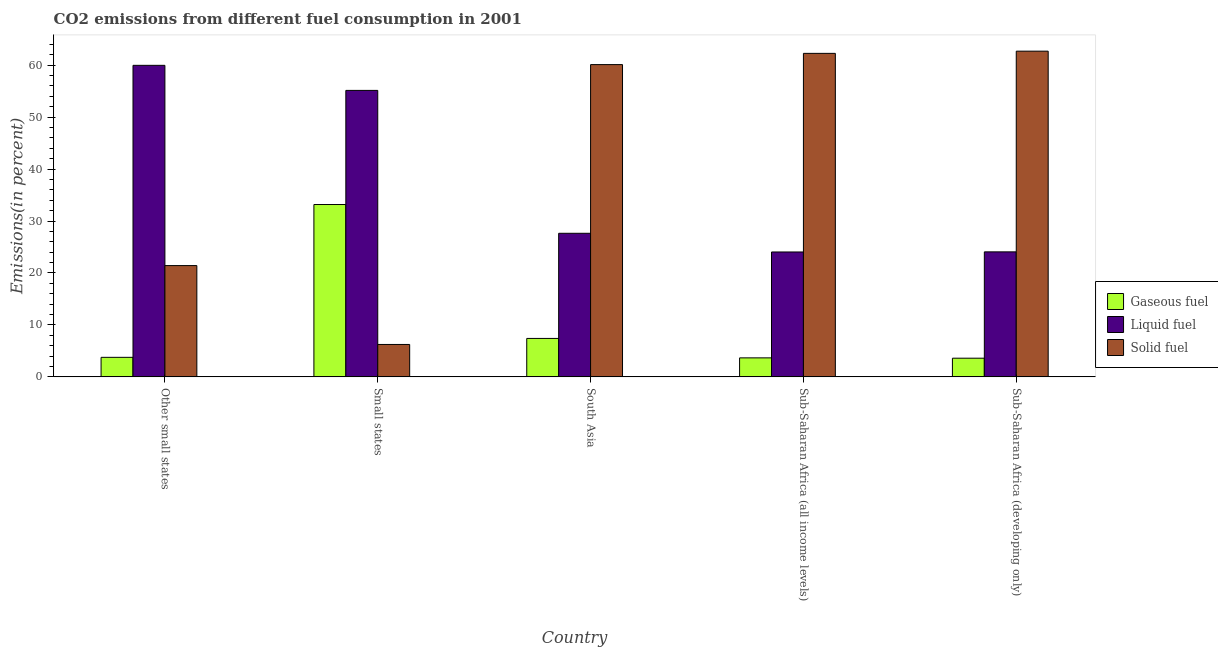Are the number of bars per tick equal to the number of legend labels?
Your answer should be compact. Yes. How many bars are there on the 2nd tick from the left?
Ensure brevity in your answer.  3. What is the label of the 5th group of bars from the left?
Keep it short and to the point. Sub-Saharan Africa (developing only). In how many cases, is the number of bars for a given country not equal to the number of legend labels?
Ensure brevity in your answer.  0. What is the percentage of liquid fuel emission in Small states?
Give a very brief answer. 55.14. Across all countries, what is the maximum percentage of solid fuel emission?
Keep it short and to the point. 62.69. Across all countries, what is the minimum percentage of gaseous fuel emission?
Offer a terse response. 3.59. In which country was the percentage of liquid fuel emission maximum?
Ensure brevity in your answer.  Other small states. In which country was the percentage of solid fuel emission minimum?
Make the answer very short. Small states. What is the total percentage of solid fuel emission in the graph?
Give a very brief answer. 212.72. What is the difference between the percentage of solid fuel emission in Small states and that in Sub-Saharan Africa (all income levels)?
Your answer should be compact. -56.03. What is the difference between the percentage of gaseous fuel emission in Sub-Saharan Africa (all income levels) and the percentage of liquid fuel emission in Other small states?
Your answer should be compact. -56.3. What is the average percentage of solid fuel emission per country?
Your answer should be compact. 42.54. What is the difference between the percentage of liquid fuel emission and percentage of solid fuel emission in Other small states?
Keep it short and to the point. 38.54. In how many countries, is the percentage of gaseous fuel emission greater than 16 %?
Your response must be concise. 1. What is the ratio of the percentage of solid fuel emission in Other small states to that in South Asia?
Your answer should be compact. 0.36. Is the difference between the percentage of gaseous fuel emission in Other small states and Small states greater than the difference between the percentage of solid fuel emission in Other small states and Small states?
Offer a very short reply. No. What is the difference between the highest and the second highest percentage of liquid fuel emission?
Give a very brief answer. 4.82. What is the difference between the highest and the lowest percentage of gaseous fuel emission?
Offer a terse response. 29.58. Is the sum of the percentage of gaseous fuel emission in Small states and South Asia greater than the maximum percentage of solid fuel emission across all countries?
Provide a succinct answer. No. What does the 2nd bar from the left in Small states represents?
Your response must be concise. Liquid fuel. What does the 2nd bar from the right in South Asia represents?
Your answer should be compact. Liquid fuel. How many bars are there?
Give a very brief answer. 15. Does the graph contain any zero values?
Provide a short and direct response. No. How many legend labels are there?
Your answer should be very brief. 3. What is the title of the graph?
Offer a terse response. CO2 emissions from different fuel consumption in 2001. What is the label or title of the Y-axis?
Your answer should be very brief. Emissions(in percent). What is the Emissions(in percent) of Gaseous fuel in Other small states?
Ensure brevity in your answer.  3.76. What is the Emissions(in percent) in Liquid fuel in Other small states?
Give a very brief answer. 59.96. What is the Emissions(in percent) of Solid fuel in Other small states?
Provide a succinct answer. 21.42. What is the Emissions(in percent) in Gaseous fuel in Small states?
Give a very brief answer. 33.17. What is the Emissions(in percent) in Liquid fuel in Small states?
Make the answer very short. 55.14. What is the Emissions(in percent) in Solid fuel in Small states?
Provide a short and direct response. 6.24. What is the Emissions(in percent) in Gaseous fuel in South Asia?
Ensure brevity in your answer.  7.4. What is the Emissions(in percent) of Liquid fuel in South Asia?
Ensure brevity in your answer.  27.63. What is the Emissions(in percent) in Solid fuel in South Asia?
Your answer should be very brief. 60.1. What is the Emissions(in percent) in Gaseous fuel in Sub-Saharan Africa (all income levels)?
Your answer should be compact. 3.66. What is the Emissions(in percent) in Liquid fuel in Sub-Saharan Africa (all income levels)?
Ensure brevity in your answer.  24.04. What is the Emissions(in percent) of Solid fuel in Sub-Saharan Africa (all income levels)?
Give a very brief answer. 62.27. What is the Emissions(in percent) in Gaseous fuel in Sub-Saharan Africa (developing only)?
Give a very brief answer. 3.59. What is the Emissions(in percent) of Liquid fuel in Sub-Saharan Africa (developing only)?
Offer a terse response. 24.06. What is the Emissions(in percent) of Solid fuel in Sub-Saharan Africa (developing only)?
Provide a short and direct response. 62.69. Across all countries, what is the maximum Emissions(in percent) of Gaseous fuel?
Provide a short and direct response. 33.17. Across all countries, what is the maximum Emissions(in percent) in Liquid fuel?
Offer a very short reply. 59.96. Across all countries, what is the maximum Emissions(in percent) in Solid fuel?
Provide a short and direct response. 62.69. Across all countries, what is the minimum Emissions(in percent) in Gaseous fuel?
Your response must be concise. 3.59. Across all countries, what is the minimum Emissions(in percent) in Liquid fuel?
Ensure brevity in your answer.  24.04. Across all countries, what is the minimum Emissions(in percent) in Solid fuel?
Make the answer very short. 6.24. What is the total Emissions(in percent) of Gaseous fuel in the graph?
Provide a succinct answer. 51.58. What is the total Emissions(in percent) in Liquid fuel in the graph?
Ensure brevity in your answer.  190.84. What is the total Emissions(in percent) in Solid fuel in the graph?
Offer a very short reply. 212.72. What is the difference between the Emissions(in percent) in Gaseous fuel in Other small states and that in Small states?
Provide a succinct answer. -29.41. What is the difference between the Emissions(in percent) in Liquid fuel in Other small states and that in Small states?
Your answer should be compact. 4.82. What is the difference between the Emissions(in percent) of Solid fuel in Other small states and that in Small states?
Make the answer very short. 15.18. What is the difference between the Emissions(in percent) in Gaseous fuel in Other small states and that in South Asia?
Provide a succinct answer. -3.64. What is the difference between the Emissions(in percent) of Liquid fuel in Other small states and that in South Asia?
Your answer should be compact. 32.33. What is the difference between the Emissions(in percent) of Solid fuel in Other small states and that in South Asia?
Offer a terse response. -38.69. What is the difference between the Emissions(in percent) in Gaseous fuel in Other small states and that in Sub-Saharan Africa (all income levels)?
Offer a terse response. 0.1. What is the difference between the Emissions(in percent) of Liquid fuel in Other small states and that in Sub-Saharan Africa (all income levels)?
Your response must be concise. 35.92. What is the difference between the Emissions(in percent) in Solid fuel in Other small states and that in Sub-Saharan Africa (all income levels)?
Make the answer very short. -40.85. What is the difference between the Emissions(in percent) in Gaseous fuel in Other small states and that in Sub-Saharan Africa (developing only)?
Provide a succinct answer. 0.17. What is the difference between the Emissions(in percent) in Liquid fuel in Other small states and that in Sub-Saharan Africa (developing only)?
Provide a short and direct response. 35.9. What is the difference between the Emissions(in percent) in Solid fuel in Other small states and that in Sub-Saharan Africa (developing only)?
Offer a very short reply. -41.27. What is the difference between the Emissions(in percent) of Gaseous fuel in Small states and that in South Asia?
Your response must be concise. 25.77. What is the difference between the Emissions(in percent) in Liquid fuel in Small states and that in South Asia?
Keep it short and to the point. 27.5. What is the difference between the Emissions(in percent) in Solid fuel in Small states and that in South Asia?
Give a very brief answer. -53.87. What is the difference between the Emissions(in percent) of Gaseous fuel in Small states and that in Sub-Saharan Africa (all income levels)?
Give a very brief answer. 29.51. What is the difference between the Emissions(in percent) of Liquid fuel in Small states and that in Sub-Saharan Africa (all income levels)?
Make the answer very short. 31.1. What is the difference between the Emissions(in percent) in Solid fuel in Small states and that in Sub-Saharan Africa (all income levels)?
Ensure brevity in your answer.  -56.03. What is the difference between the Emissions(in percent) of Gaseous fuel in Small states and that in Sub-Saharan Africa (developing only)?
Provide a succinct answer. 29.58. What is the difference between the Emissions(in percent) of Liquid fuel in Small states and that in Sub-Saharan Africa (developing only)?
Give a very brief answer. 31.08. What is the difference between the Emissions(in percent) of Solid fuel in Small states and that in Sub-Saharan Africa (developing only)?
Keep it short and to the point. -56.45. What is the difference between the Emissions(in percent) of Gaseous fuel in South Asia and that in Sub-Saharan Africa (all income levels)?
Keep it short and to the point. 3.74. What is the difference between the Emissions(in percent) in Liquid fuel in South Asia and that in Sub-Saharan Africa (all income levels)?
Your answer should be compact. 3.6. What is the difference between the Emissions(in percent) in Solid fuel in South Asia and that in Sub-Saharan Africa (all income levels)?
Offer a terse response. -2.16. What is the difference between the Emissions(in percent) in Gaseous fuel in South Asia and that in Sub-Saharan Africa (developing only)?
Keep it short and to the point. 3.8. What is the difference between the Emissions(in percent) in Liquid fuel in South Asia and that in Sub-Saharan Africa (developing only)?
Ensure brevity in your answer.  3.57. What is the difference between the Emissions(in percent) in Solid fuel in South Asia and that in Sub-Saharan Africa (developing only)?
Make the answer very short. -2.59. What is the difference between the Emissions(in percent) of Gaseous fuel in Sub-Saharan Africa (all income levels) and that in Sub-Saharan Africa (developing only)?
Your answer should be very brief. 0.06. What is the difference between the Emissions(in percent) of Liquid fuel in Sub-Saharan Africa (all income levels) and that in Sub-Saharan Africa (developing only)?
Offer a terse response. -0.02. What is the difference between the Emissions(in percent) in Solid fuel in Sub-Saharan Africa (all income levels) and that in Sub-Saharan Africa (developing only)?
Give a very brief answer. -0.42. What is the difference between the Emissions(in percent) of Gaseous fuel in Other small states and the Emissions(in percent) of Liquid fuel in Small states?
Your answer should be compact. -51.38. What is the difference between the Emissions(in percent) in Gaseous fuel in Other small states and the Emissions(in percent) in Solid fuel in Small states?
Make the answer very short. -2.48. What is the difference between the Emissions(in percent) in Liquid fuel in Other small states and the Emissions(in percent) in Solid fuel in Small states?
Give a very brief answer. 53.72. What is the difference between the Emissions(in percent) in Gaseous fuel in Other small states and the Emissions(in percent) in Liquid fuel in South Asia?
Offer a very short reply. -23.87. What is the difference between the Emissions(in percent) in Gaseous fuel in Other small states and the Emissions(in percent) in Solid fuel in South Asia?
Your answer should be compact. -56.34. What is the difference between the Emissions(in percent) of Liquid fuel in Other small states and the Emissions(in percent) of Solid fuel in South Asia?
Your answer should be compact. -0.14. What is the difference between the Emissions(in percent) of Gaseous fuel in Other small states and the Emissions(in percent) of Liquid fuel in Sub-Saharan Africa (all income levels)?
Ensure brevity in your answer.  -20.28. What is the difference between the Emissions(in percent) of Gaseous fuel in Other small states and the Emissions(in percent) of Solid fuel in Sub-Saharan Africa (all income levels)?
Ensure brevity in your answer.  -58.51. What is the difference between the Emissions(in percent) in Liquid fuel in Other small states and the Emissions(in percent) in Solid fuel in Sub-Saharan Africa (all income levels)?
Provide a succinct answer. -2.3. What is the difference between the Emissions(in percent) of Gaseous fuel in Other small states and the Emissions(in percent) of Liquid fuel in Sub-Saharan Africa (developing only)?
Provide a succinct answer. -20.3. What is the difference between the Emissions(in percent) of Gaseous fuel in Other small states and the Emissions(in percent) of Solid fuel in Sub-Saharan Africa (developing only)?
Ensure brevity in your answer.  -58.93. What is the difference between the Emissions(in percent) of Liquid fuel in Other small states and the Emissions(in percent) of Solid fuel in Sub-Saharan Africa (developing only)?
Provide a succinct answer. -2.73. What is the difference between the Emissions(in percent) in Gaseous fuel in Small states and the Emissions(in percent) in Liquid fuel in South Asia?
Ensure brevity in your answer.  5.54. What is the difference between the Emissions(in percent) of Gaseous fuel in Small states and the Emissions(in percent) of Solid fuel in South Asia?
Provide a short and direct response. -26.93. What is the difference between the Emissions(in percent) in Liquid fuel in Small states and the Emissions(in percent) in Solid fuel in South Asia?
Make the answer very short. -4.97. What is the difference between the Emissions(in percent) of Gaseous fuel in Small states and the Emissions(in percent) of Liquid fuel in Sub-Saharan Africa (all income levels)?
Provide a succinct answer. 9.13. What is the difference between the Emissions(in percent) in Gaseous fuel in Small states and the Emissions(in percent) in Solid fuel in Sub-Saharan Africa (all income levels)?
Ensure brevity in your answer.  -29.1. What is the difference between the Emissions(in percent) in Liquid fuel in Small states and the Emissions(in percent) in Solid fuel in Sub-Saharan Africa (all income levels)?
Ensure brevity in your answer.  -7.13. What is the difference between the Emissions(in percent) in Gaseous fuel in Small states and the Emissions(in percent) in Liquid fuel in Sub-Saharan Africa (developing only)?
Make the answer very short. 9.11. What is the difference between the Emissions(in percent) in Gaseous fuel in Small states and the Emissions(in percent) in Solid fuel in Sub-Saharan Africa (developing only)?
Give a very brief answer. -29.52. What is the difference between the Emissions(in percent) in Liquid fuel in Small states and the Emissions(in percent) in Solid fuel in Sub-Saharan Africa (developing only)?
Provide a short and direct response. -7.55. What is the difference between the Emissions(in percent) in Gaseous fuel in South Asia and the Emissions(in percent) in Liquid fuel in Sub-Saharan Africa (all income levels)?
Provide a short and direct response. -16.64. What is the difference between the Emissions(in percent) in Gaseous fuel in South Asia and the Emissions(in percent) in Solid fuel in Sub-Saharan Africa (all income levels)?
Your answer should be compact. -54.87. What is the difference between the Emissions(in percent) of Liquid fuel in South Asia and the Emissions(in percent) of Solid fuel in Sub-Saharan Africa (all income levels)?
Your response must be concise. -34.63. What is the difference between the Emissions(in percent) in Gaseous fuel in South Asia and the Emissions(in percent) in Liquid fuel in Sub-Saharan Africa (developing only)?
Offer a very short reply. -16.66. What is the difference between the Emissions(in percent) in Gaseous fuel in South Asia and the Emissions(in percent) in Solid fuel in Sub-Saharan Africa (developing only)?
Your answer should be compact. -55.29. What is the difference between the Emissions(in percent) of Liquid fuel in South Asia and the Emissions(in percent) of Solid fuel in Sub-Saharan Africa (developing only)?
Make the answer very short. -35.06. What is the difference between the Emissions(in percent) of Gaseous fuel in Sub-Saharan Africa (all income levels) and the Emissions(in percent) of Liquid fuel in Sub-Saharan Africa (developing only)?
Offer a very short reply. -20.4. What is the difference between the Emissions(in percent) in Gaseous fuel in Sub-Saharan Africa (all income levels) and the Emissions(in percent) in Solid fuel in Sub-Saharan Africa (developing only)?
Your answer should be compact. -59.03. What is the difference between the Emissions(in percent) of Liquid fuel in Sub-Saharan Africa (all income levels) and the Emissions(in percent) of Solid fuel in Sub-Saharan Africa (developing only)?
Make the answer very short. -38.65. What is the average Emissions(in percent) in Gaseous fuel per country?
Ensure brevity in your answer.  10.32. What is the average Emissions(in percent) of Liquid fuel per country?
Offer a terse response. 38.17. What is the average Emissions(in percent) in Solid fuel per country?
Offer a very short reply. 42.54. What is the difference between the Emissions(in percent) of Gaseous fuel and Emissions(in percent) of Liquid fuel in Other small states?
Offer a terse response. -56.2. What is the difference between the Emissions(in percent) of Gaseous fuel and Emissions(in percent) of Solid fuel in Other small states?
Provide a succinct answer. -17.66. What is the difference between the Emissions(in percent) in Liquid fuel and Emissions(in percent) in Solid fuel in Other small states?
Your response must be concise. 38.54. What is the difference between the Emissions(in percent) of Gaseous fuel and Emissions(in percent) of Liquid fuel in Small states?
Give a very brief answer. -21.97. What is the difference between the Emissions(in percent) in Gaseous fuel and Emissions(in percent) in Solid fuel in Small states?
Offer a very short reply. 26.93. What is the difference between the Emissions(in percent) of Liquid fuel and Emissions(in percent) of Solid fuel in Small states?
Your response must be concise. 48.9. What is the difference between the Emissions(in percent) in Gaseous fuel and Emissions(in percent) in Liquid fuel in South Asia?
Your response must be concise. -20.24. What is the difference between the Emissions(in percent) in Gaseous fuel and Emissions(in percent) in Solid fuel in South Asia?
Provide a succinct answer. -52.71. What is the difference between the Emissions(in percent) of Liquid fuel and Emissions(in percent) of Solid fuel in South Asia?
Keep it short and to the point. -32.47. What is the difference between the Emissions(in percent) in Gaseous fuel and Emissions(in percent) in Liquid fuel in Sub-Saharan Africa (all income levels)?
Your answer should be very brief. -20.38. What is the difference between the Emissions(in percent) in Gaseous fuel and Emissions(in percent) in Solid fuel in Sub-Saharan Africa (all income levels)?
Your answer should be very brief. -58.61. What is the difference between the Emissions(in percent) of Liquid fuel and Emissions(in percent) of Solid fuel in Sub-Saharan Africa (all income levels)?
Offer a terse response. -38.23. What is the difference between the Emissions(in percent) of Gaseous fuel and Emissions(in percent) of Liquid fuel in Sub-Saharan Africa (developing only)?
Offer a very short reply. -20.47. What is the difference between the Emissions(in percent) of Gaseous fuel and Emissions(in percent) of Solid fuel in Sub-Saharan Africa (developing only)?
Your answer should be very brief. -59.1. What is the difference between the Emissions(in percent) of Liquid fuel and Emissions(in percent) of Solid fuel in Sub-Saharan Africa (developing only)?
Provide a succinct answer. -38.63. What is the ratio of the Emissions(in percent) in Gaseous fuel in Other small states to that in Small states?
Offer a terse response. 0.11. What is the ratio of the Emissions(in percent) of Liquid fuel in Other small states to that in Small states?
Offer a terse response. 1.09. What is the ratio of the Emissions(in percent) in Solid fuel in Other small states to that in Small states?
Your response must be concise. 3.43. What is the ratio of the Emissions(in percent) in Gaseous fuel in Other small states to that in South Asia?
Make the answer very short. 0.51. What is the ratio of the Emissions(in percent) of Liquid fuel in Other small states to that in South Asia?
Your answer should be very brief. 2.17. What is the ratio of the Emissions(in percent) of Solid fuel in Other small states to that in South Asia?
Provide a short and direct response. 0.36. What is the ratio of the Emissions(in percent) of Gaseous fuel in Other small states to that in Sub-Saharan Africa (all income levels)?
Offer a very short reply. 1.03. What is the ratio of the Emissions(in percent) in Liquid fuel in Other small states to that in Sub-Saharan Africa (all income levels)?
Your answer should be very brief. 2.49. What is the ratio of the Emissions(in percent) of Solid fuel in Other small states to that in Sub-Saharan Africa (all income levels)?
Your answer should be compact. 0.34. What is the ratio of the Emissions(in percent) in Gaseous fuel in Other small states to that in Sub-Saharan Africa (developing only)?
Give a very brief answer. 1.05. What is the ratio of the Emissions(in percent) in Liquid fuel in Other small states to that in Sub-Saharan Africa (developing only)?
Offer a very short reply. 2.49. What is the ratio of the Emissions(in percent) of Solid fuel in Other small states to that in Sub-Saharan Africa (developing only)?
Provide a succinct answer. 0.34. What is the ratio of the Emissions(in percent) of Gaseous fuel in Small states to that in South Asia?
Your answer should be very brief. 4.48. What is the ratio of the Emissions(in percent) of Liquid fuel in Small states to that in South Asia?
Your answer should be compact. 2. What is the ratio of the Emissions(in percent) in Solid fuel in Small states to that in South Asia?
Give a very brief answer. 0.1. What is the ratio of the Emissions(in percent) in Gaseous fuel in Small states to that in Sub-Saharan Africa (all income levels)?
Keep it short and to the point. 9.07. What is the ratio of the Emissions(in percent) of Liquid fuel in Small states to that in Sub-Saharan Africa (all income levels)?
Provide a succinct answer. 2.29. What is the ratio of the Emissions(in percent) of Solid fuel in Small states to that in Sub-Saharan Africa (all income levels)?
Make the answer very short. 0.1. What is the ratio of the Emissions(in percent) in Gaseous fuel in Small states to that in Sub-Saharan Africa (developing only)?
Provide a short and direct response. 9.23. What is the ratio of the Emissions(in percent) of Liquid fuel in Small states to that in Sub-Saharan Africa (developing only)?
Give a very brief answer. 2.29. What is the ratio of the Emissions(in percent) of Solid fuel in Small states to that in Sub-Saharan Africa (developing only)?
Make the answer very short. 0.1. What is the ratio of the Emissions(in percent) of Gaseous fuel in South Asia to that in Sub-Saharan Africa (all income levels)?
Provide a succinct answer. 2.02. What is the ratio of the Emissions(in percent) of Liquid fuel in South Asia to that in Sub-Saharan Africa (all income levels)?
Offer a terse response. 1.15. What is the ratio of the Emissions(in percent) in Solid fuel in South Asia to that in Sub-Saharan Africa (all income levels)?
Make the answer very short. 0.97. What is the ratio of the Emissions(in percent) of Gaseous fuel in South Asia to that in Sub-Saharan Africa (developing only)?
Offer a terse response. 2.06. What is the ratio of the Emissions(in percent) of Liquid fuel in South Asia to that in Sub-Saharan Africa (developing only)?
Your answer should be very brief. 1.15. What is the ratio of the Emissions(in percent) in Solid fuel in South Asia to that in Sub-Saharan Africa (developing only)?
Offer a very short reply. 0.96. What is the ratio of the Emissions(in percent) of Gaseous fuel in Sub-Saharan Africa (all income levels) to that in Sub-Saharan Africa (developing only)?
Your answer should be compact. 1.02. What is the ratio of the Emissions(in percent) of Liquid fuel in Sub-Saharan Africa (all income levels) to that in Sub-Saharan Africa (developing only)?
Ensure brevity in your answer.  1. What is the ratio of the Emissions(in percent) of Solid fuel in Sub-Saharan Africa (all income levels) to that in Sub-Saharan Africa (developing only)?
Your answer should be very brief. 0.99. What is the difference between the highest and the second highest Emissions(in percent) in Gaseous fuel?
Offer a terse response. 25.77. What is the difference between the highest and the second highest Emissions(in percent) in Liquid fuel?
Offer a terse response. 4.82. What is the difference between the highest and the second highest Emissions(in percent) of Solid fuel?
Keep it short and to the point. 0.42. What is the difference between the highest and the lowest Emissions(in percent) of Gaseous fuel?
Offer a very short reply. 29.58. What is the difference between the highest and the lowest Emissions(in percent) in Liquid fuel?
Give a very brief answer. 35.92. What is the difference between the highest and the lowest Emissions(in percent) in Solid fuel?
Make the answer very short. 56.45. 